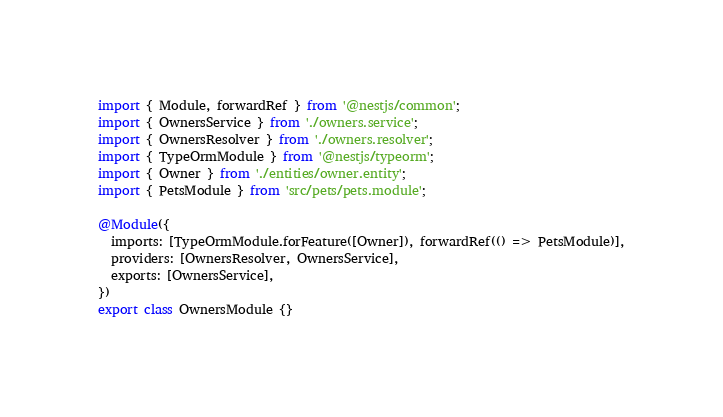<code> <loc_0><loc_0><loc_500><loc_500><_TypeScript_>import { Module, forwardRef } from '@nestjs/common';
import { OwnersService } from './owners.service';
import { OwnersResolver } from './owners.resolver';
import { TypeOrmModule } from '@nestjs/typeorm';
import { Owner } from './entities/owner.entity';
import { PetsModule } from 'src/pets/pets.module';

@Module({
  imports: [TypeOrmModule.forFeature([Owner]), forwardRef(() => PetsModule)],
  providers: [OwnersResolver, OwnersService],
  exports: [OwnersService],
})
export class OwnersModule {}
</code> 